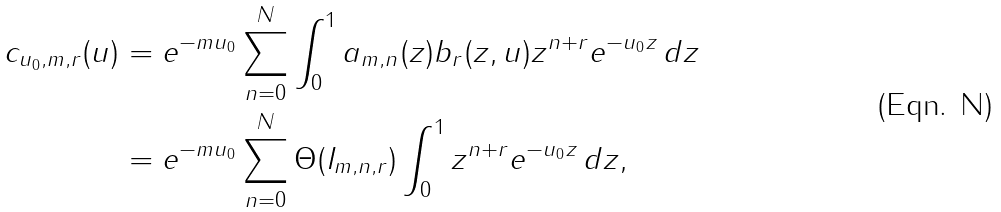<formula> <loc_0><loc_0><loc_500><loc_500>c _ { u _ { 0 } , m , r } ( u ) & = e ^ { - m u _ { 0 } } \sum _ { n = 0 } ^ { N } \int _ { 0 } ^ { 1 } a _ { m , n } ( z ) b _ { r } ( z , u ) z ^ { n + r } e ^ { - u _ { 0 } z } \, d z \\ & = e ^ { - m u _ { 0 } } \sum _ { n = 0 } ^ { N } \Theta ( I _ { m , n , r } ) \int _ { 0 } ^ { 1 } z ^ { n + r } e ^ { - u _ { 0 } z } \, d z ,</formula> 